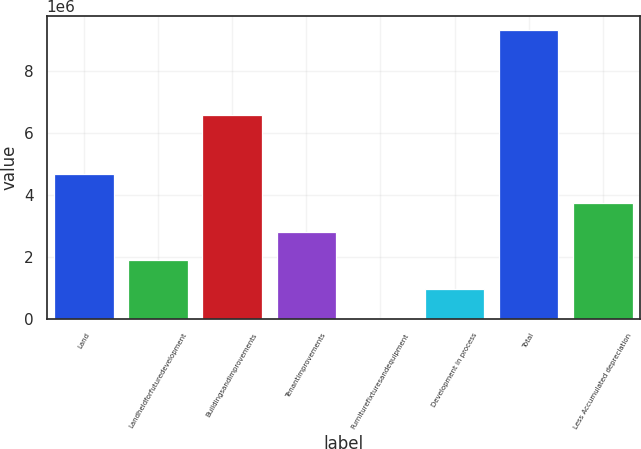<chart> <loc_0><loc_0><loc_500><loc_500><bar_chart><fcel>Land<fcel>Landheldforfuturedevelopment<fcel>Buildingsandimprovements<fcel>Tenantimprovements<fcel>Furniturefixturesandequipment<fcel>Development in process<fcel>Total<fcel>Less Accumulated depreciation<nl><fcel>4.66291e+06<fcel>1.88592e+06<fcel>6.56034e+06<fcel>2.81158e+06<fcel>34590<fcel>960254<fcel>9.29123e+06<fcel>3.73724e+06<nl></chart> 